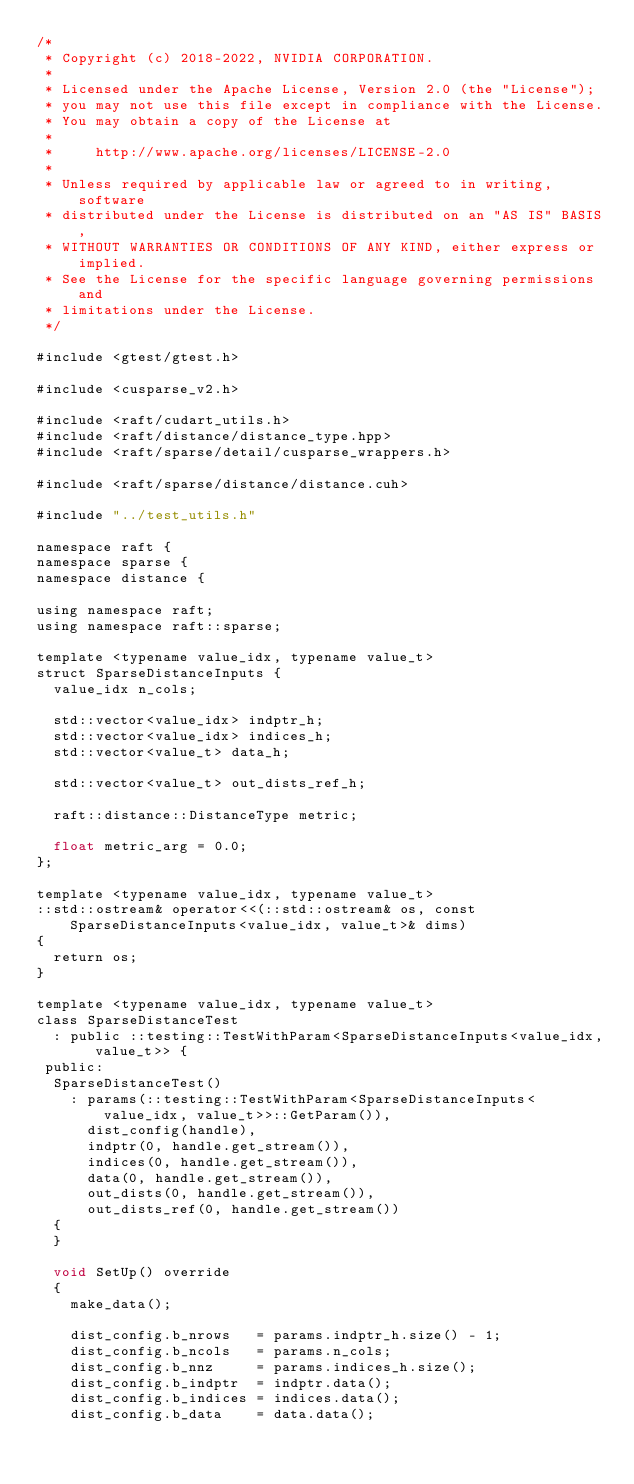Convert code to text. <code><loc_0><loc_0><loc_500><loc_500><_Cuda_>/*
 * Copyright (c) 2018-2022, NVIDIA CORPORATION.
 *
 * Licensed under the Apache License, Version 2.0 (the "License");
 * you may not use this file except in compliance with the License.
 * You may obtain a copy of the License at
 *
 *     http://www.apache.org/licenses/LICENSE-2.0
 *
 * Unless required by applicable law or agreed to in writing, software
 * distributed under the License is distributed on an "AS IS" BASIS,
 * WITHOUT WARRANTIES OR CONDITIONS OF ANY KIND, either express or implied.
 * See the License for the specific language governing permissions and
 * limitations under the License.
 */

#include <gtest/gtest.h>

#include <cusparse_v2.h>

#include <raft/cudart_utils.h>
#include <raft/distance/distance_type.hpp>
#include <raft/sparse/detail/cusparse_wrappers.h>

#include <raft/sparse/distance/distance.cuh>

#include "../test_utils.h"

namespace raft {
namespace sparse {
namespace distance {

using namespace raft;
using namespace raft::sparse;

template <typename value_idx, typename value_t>
struct SparseDistanceInputs {
  value_idx n_cols;

  std::vector<value_idx> indptr_h;
  std::vector<value_idx> indices_h;
  std::vector<value_t> data_h;

  std::vector<value_t> out_dists_ref_h;

  raft::distance::DistanceType metric;

  float metric_arg = 0.0;
};

template <typename value_idx, typename value_t>
::std::ostream& operator<<(::std::ostream& os, const SparseDistanceInputs<value_idx, value_t>& dims)
{
  return os;
}

template <typename value_idx, typename value_t>
class SparseDistanceTest
  : public ::testing::TestWithParam<SparseDistanceInputs<value_idx, value_t>> {
 public:
  SparseDistanceTest()
    : params(::testing::TestWithParam<SparseDistanceInputs<value_idx, value_t>>::GetParam()),
      dist_config(handle),
      indptr(0, handle.get_stream()),
      indices(0, handle.get_stream()),
      data(0, handle.get_stream()),
      out_dists(0, handle.get_stream()),
      out_dists_ref(0, handle.get_stream())
  {
  }

  void SetUp() override
  {
    make_data();

    dist_config.b_nrows   = params.indptr_h.size() - 1;
    dist_config.b_ncols   = params.n_cols;
    dist_config.b_nnz     = params.indices_h.size();
    dist_config.b_indptr  = indptr.data();
    dist_config.b_indices = indices.data();
    dist_config.b_data    = data.data();</code> 